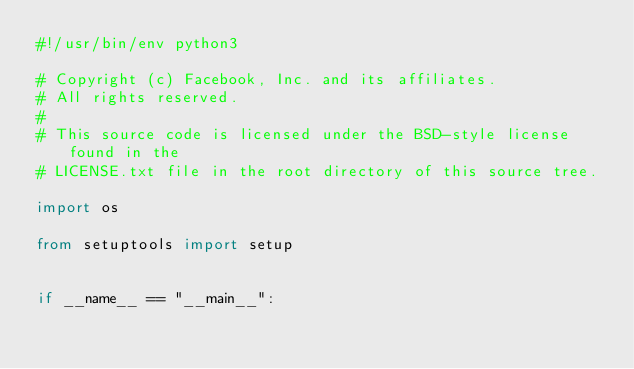<code> <loc_0><loc_0><loc_500><loc_500><_Python_>#!/usr/bin/env python3

# Copyright (c) Facebook, Inc. and its affiliates.
# All rights reserved.
#
# This source code is licensed under the BSD-style license found in the
# LICENSE.txt file in the root directory of this source tree.

import os

from setuptools import setup


if __name__ == "__main__":</code> 